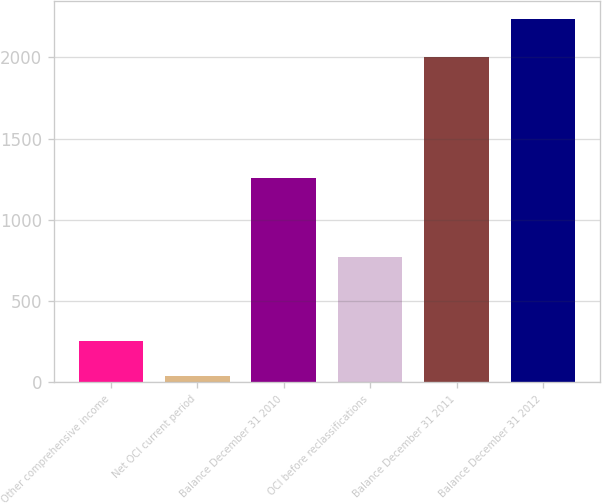<chart> <loc_0><loc_0><loc_500><loc_500><bar_chart><fcel>Other comprehensive income<fcel>Net OCI current period<fcel>Balance December 31 2010<fcel>OCI before reclassifications<fcel>Balance December 31 2011<fcel>Balance December 31 2012<nl><fcel>256<fcel>36<fcel>1255<fcel>771<fcel>2005<fcel>2236<nl></chart> 